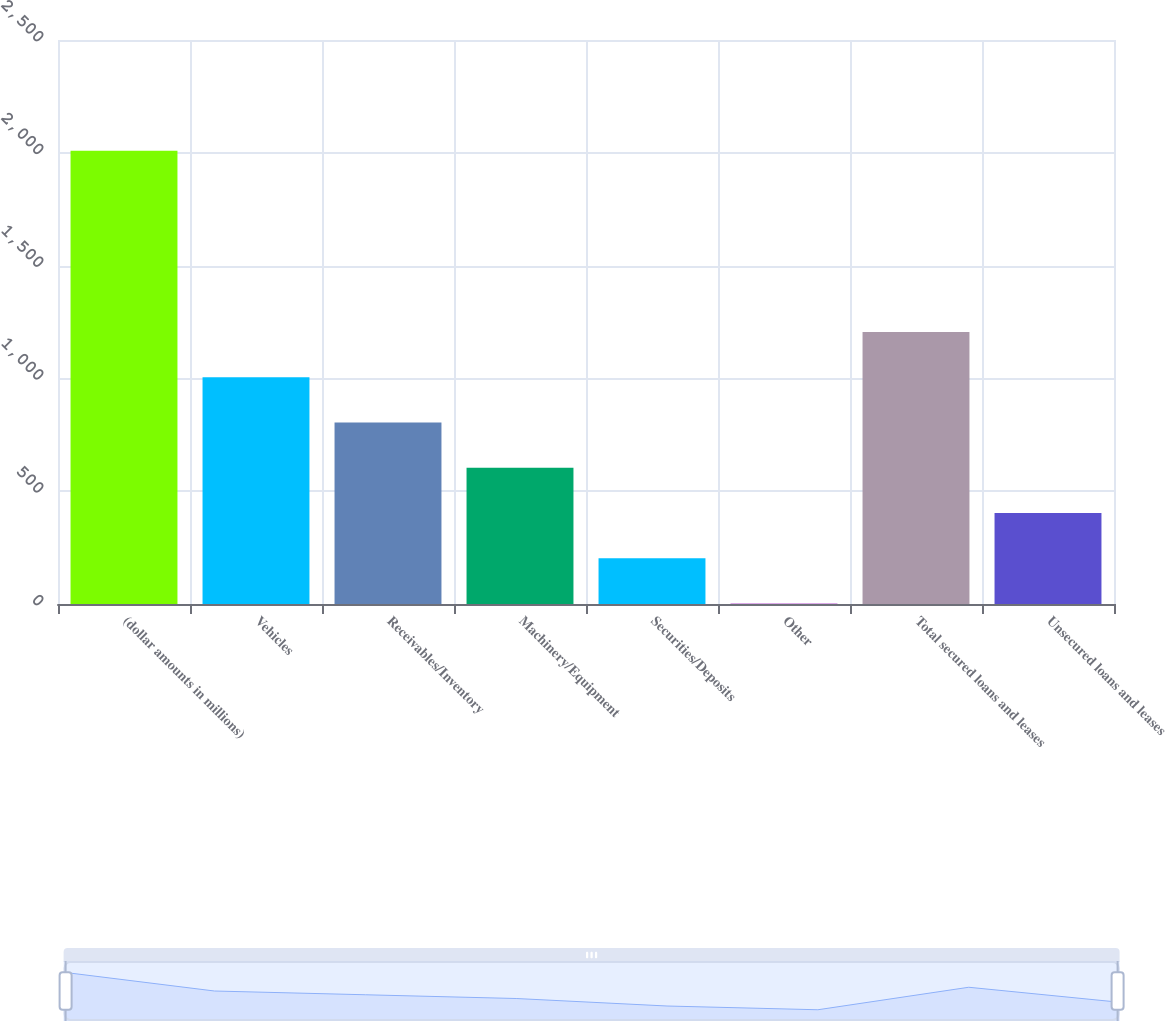Convert chart to OTSL. <chart><loc_0><loc_0><loc_500><loc_500><bar_chart><fcel>(dollar amounts in millions)<fcel>Vehicles<fcel>Receivables/Inventory<fcel>Machinery/Equipment<fcel>Securities/Deposits<fcel>Other<fcel>Total secured loans and leases<fcel>Unsecured loans and leases<nl><fcel>2009<fcel>1005.5<fcel>804.8<fcel>604.1<fcel>202.7<fcel>2<fcel>1206.2<fcel>403.4<nl></chart> 